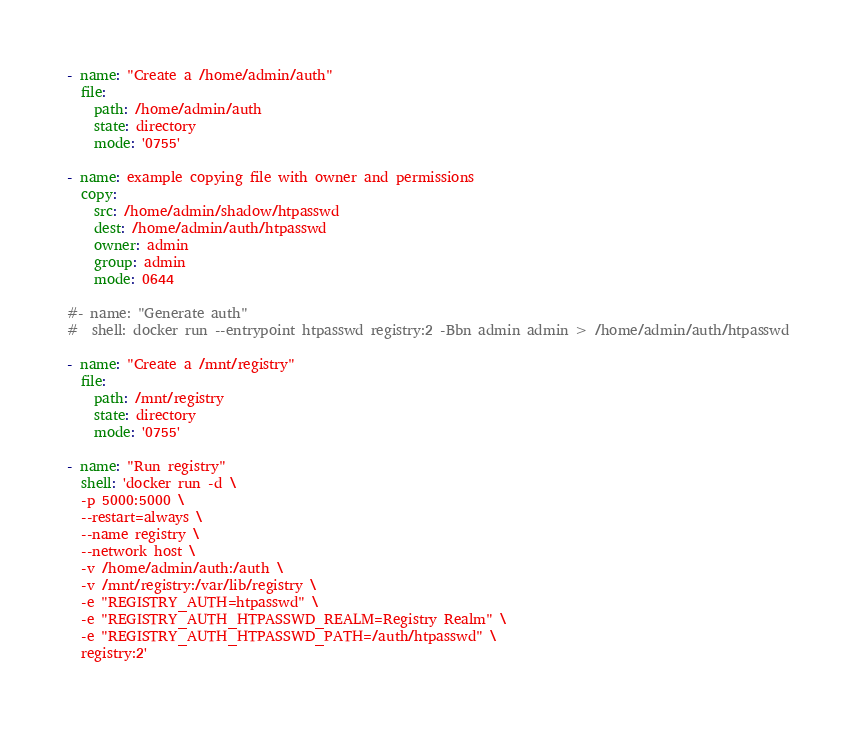<code> <loc_0><loc_0><loc_500><loc_500><_YAML_>- name: "Create a /home/admin/auth"
  file:
    path: /home/admin/auth
    state: directory
    mode: '0755'

- name: example copying file with owner and permissions
  copy:
    src: /home/admin/shadow/htpasswd
    dest: /home/admin/auth/htpasswd
    owner: admin
    group: admin
    mode: 0644
    
#- name: "Generate auth"
#  shell: docker run --entrypoint htpasswd registry:2 -Bbn admin admin > /home/admin/auth/htpasswd

- name: "Create a /mnt/registry"
  file:
    path: /mnt/registry
    state: directory
    mode: '0755'

- name: "Run registry"
  shell: 'docker run -d \
  -p 5000:5000 \
  --restart=always \
  --name registry \
  --network host \
  -v /home/admin/auth:/auth \
  -v /mnt/registry:/var/lib/registry \
  -e "REGISTRY_AUTH=htpasswd" \
  -e "REGISTRY_AUTH_HTPASSWD_REALM=Registry Realm" \
  -e "REGISTRY_AUTH_HTPASSWD_PATH=/auth/htpasswd" \
  registry:2'
</code> 